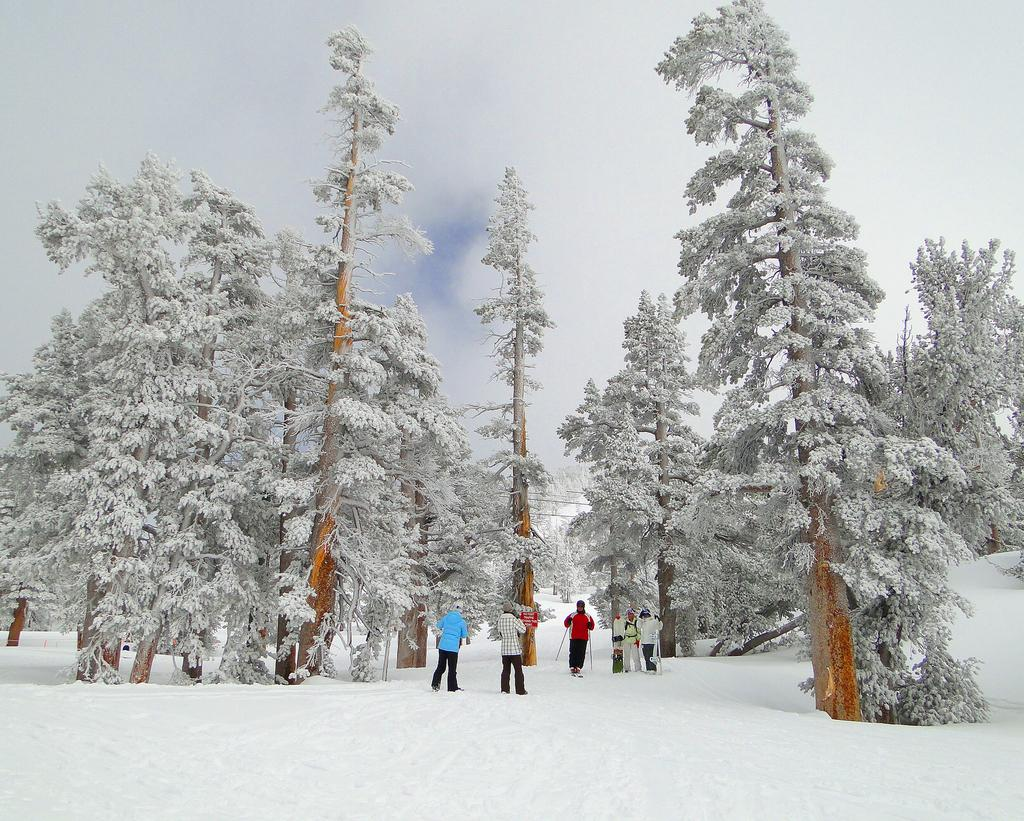How many people are in the image? There are persons in the image, but the exact number is not specified. What is the weather like in the image? There is snow in the image, indicating a cold and wintry environment. What can be seen on the trees in the image? The trees in the image are covered with snow. What is visible in the background of the image? The sky is visible in the background of the image. What color is the orange that the person is holding in the image? There is no orange present in the image; it features persons in a snowy environment with snow-covered trees. 